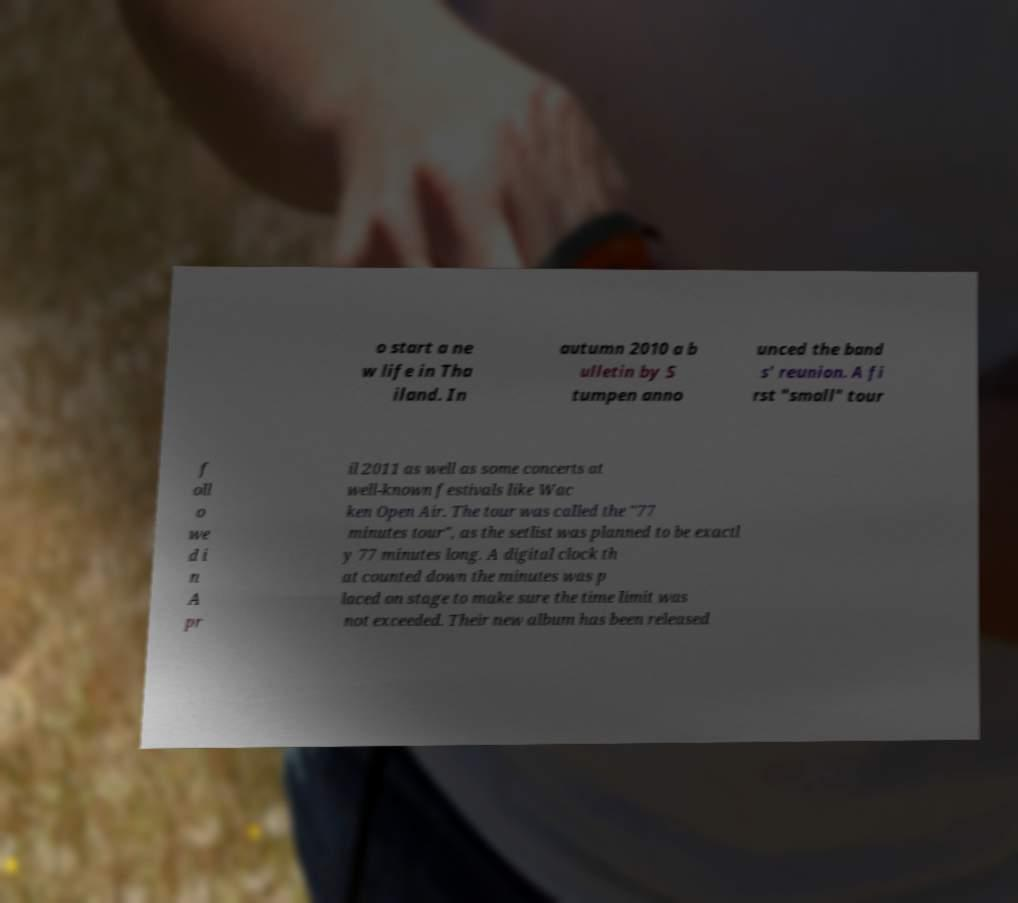Please read and relay the text visible in this image. What does it say? o start a ne w life in Tha iland. In autumn 2010 a b ulletin by S tumpen anno unced the band s' reunion. A fi rst "small" tour f oll o we d i n A pr il 2011 as well as some concerts at well-known festivals like Wac ken Open Air. The tour was called the "77 minutes tour", as the setlist was planned to be exactl y 77 minutes long. A digital clock th at counted down the minutes was p laced on stage to make sure the time limit was not exceeded. Their new album has been released 